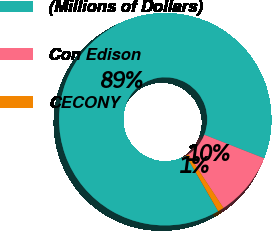Convert chart to OTSL. <chart><loc_0><loc_0><loc_500><loc_500><pie_chart><fcel>(Millions of Dollars)<fcel>Con Edison<fcel>CECONY<nl><fcel>89.3%<fcel>9.77%<fcel>0.93%<nl></chart> 